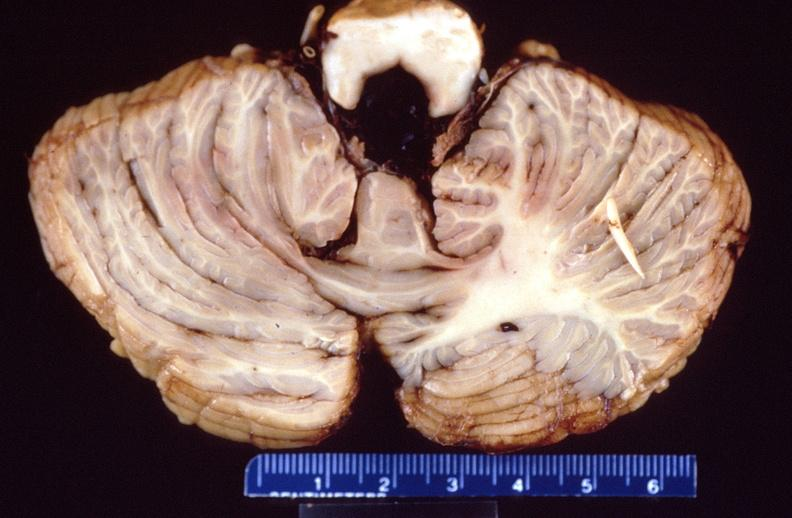does le cell show brain, intracerebral hemorrhage?
Answer the question using a single word or phrase. No 